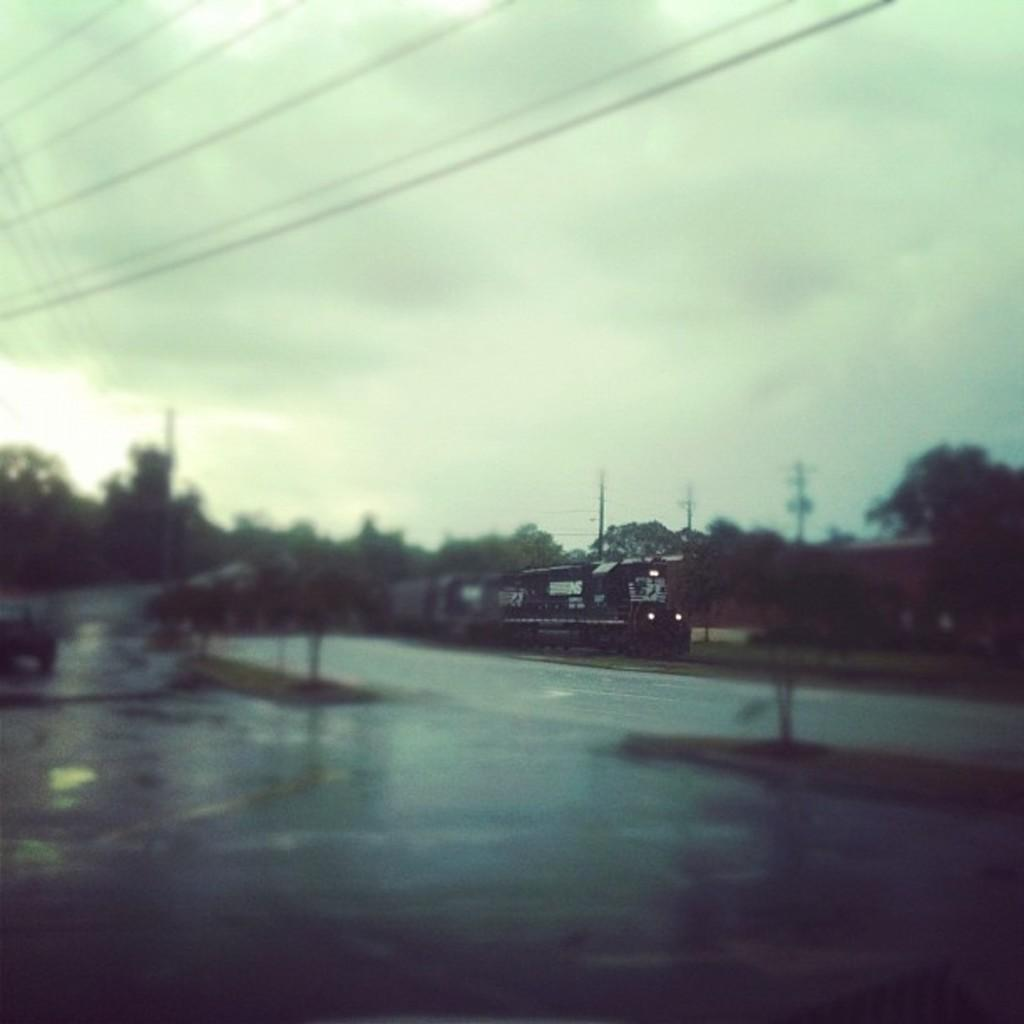What is the main subject of the picture? The main subject of the picture is a train. What is the train doing in the image? The train is moving. What type of vegetation can be seen in the image? There are plants and trees in the image. What structures are present in the image? There are electric poles in the image. What is the condition of the sky in the picture? The sky is cloudy in the image. What color is the house in the image? There is no house present in the image; it features a moving train, plants, trees, electric poles, and a cloudy sky. How many strands of hair can be seen on the train in the image? There are no strands of hair visible on the train in the image, as trains do not have hair. 